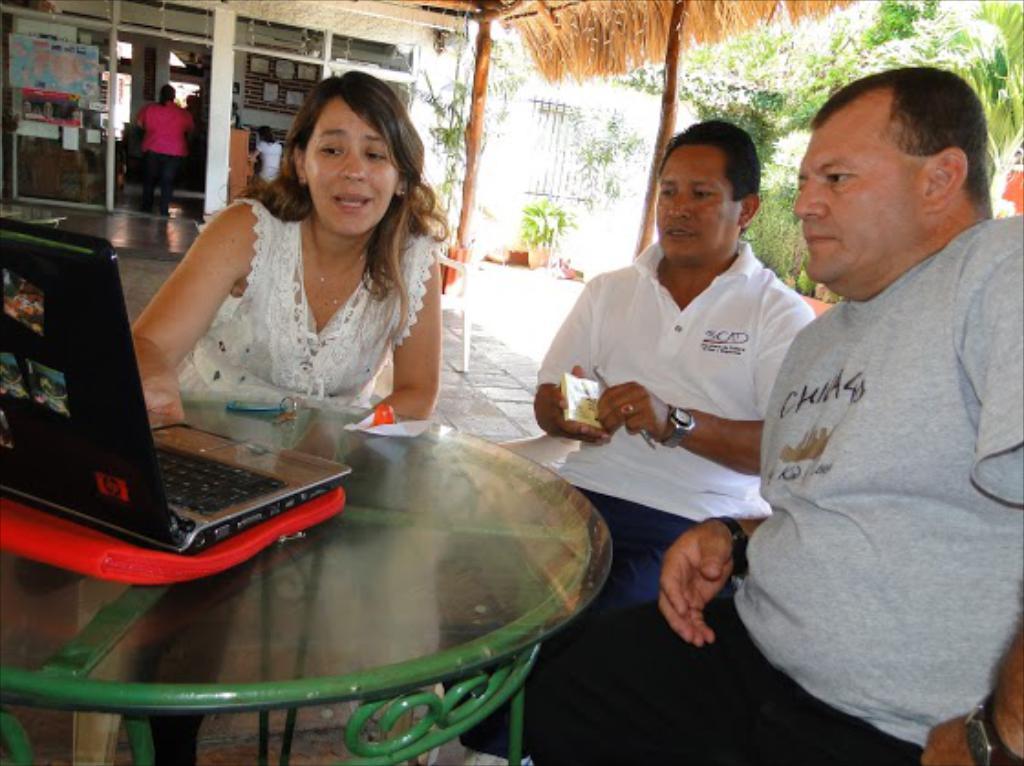Can you describe this image briefly? In this image I see 3 persons, in which one of them is a woman and 2 of them are man and all of them are in front of a table and there is a laptop on top of it. In the background I see a shop and a person in it and 2 wooden sticks and few plants. 